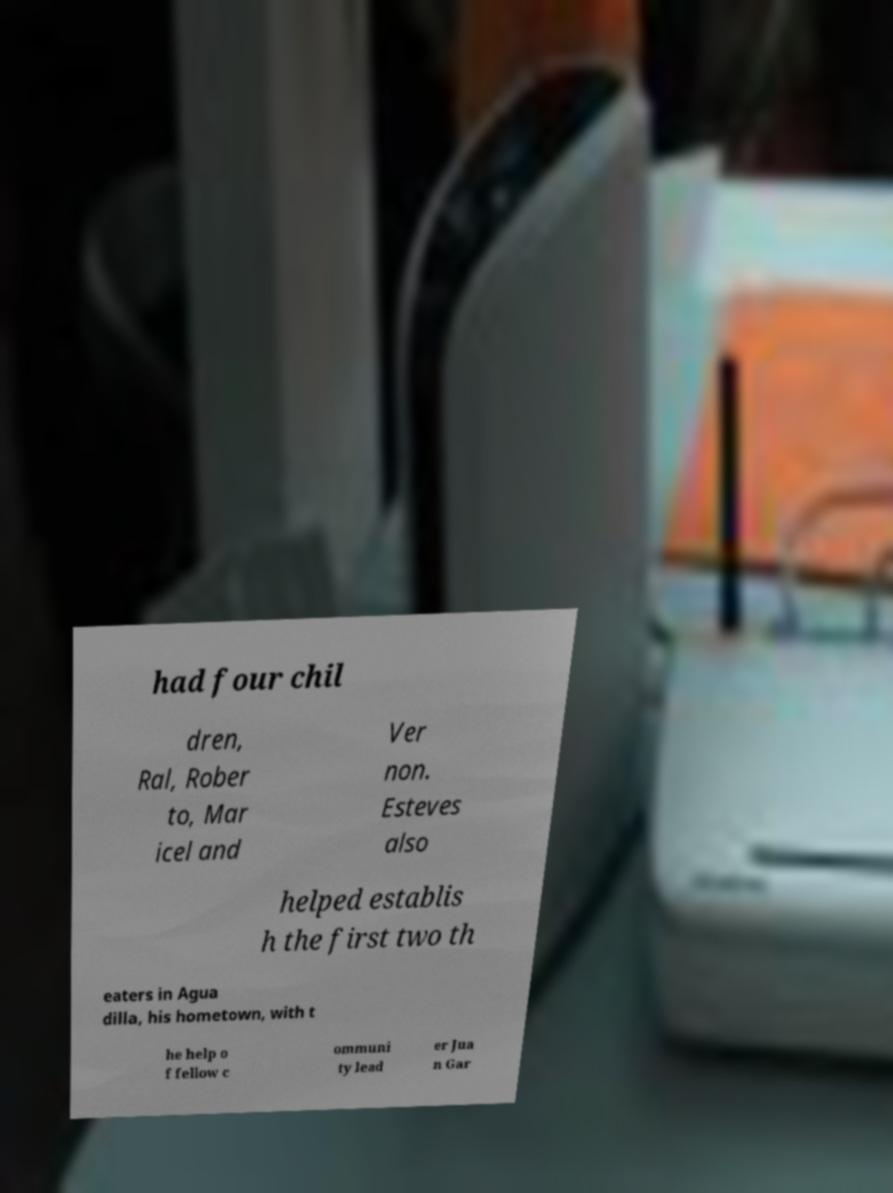I need the written content from this picture converted into text. Can you do that? had four chil dren, Ral, Rober to, Mar icel and Ver non. Esteves also helped establis h the first two th eaters in Agua dilla, his hometown, with t he help o f fellow c ommuni ty lead er Jua n Gar 